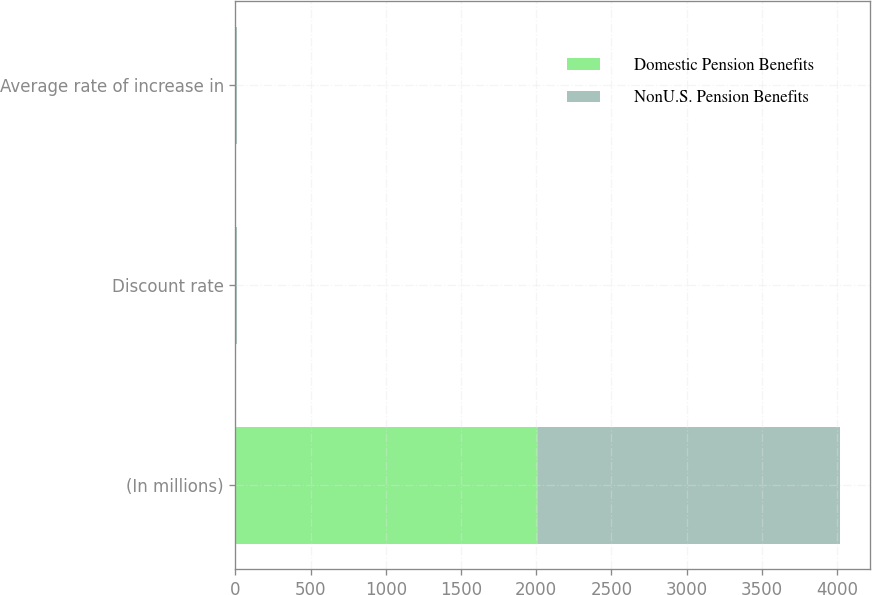Convert chart. <chart><loc_0><loc_0><loc_500><loc_500><stacked_bar_chart><ecel><fcel>(In millions)<fcel>Discount rate<fcel>Average rate of increase in<nl><fcel>Domestic Pension Benefits<fcel>2010<fcel>5.25<fcel>4<nl><fcel>NonU.S. Pension Benefits<fcel>2010<fcel>4.77<fcel>3.34<nl></chart> 